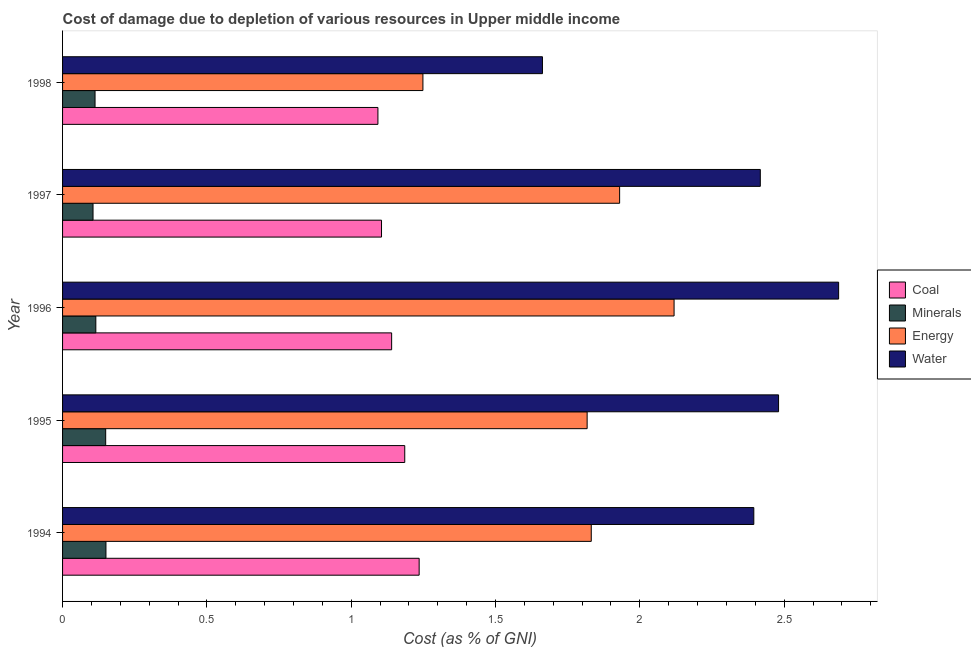How many different coloured bars are there?
Offer a terse response. 4. Are the number of bars on each tick of the Y-axis equal?
Offer a terse response. Yes. How many bars are there on the 3rd tick from the top?
Your answer should be very brief. 4. How many bars are there on the 3rd tick from the bottom?
Your answer should be compact. 4. What is the label of the 3rd group of bars from the top?
Your answer should be very brief. 1996. In how many cases, is the number of bars for a given year not equal to the number of legend labels?
Your response must be concise. 0. What is the cost of damage due to depletion of energy in 1997?
Provide a short and direct response. 1.93. Across all years, what is the maximum cost of damage due to depletion of energy?
Make the answer very short. 2.12. Across all years, what is the minimum cost of damage due to depletion of water?
Give a very brief answer. 1.66. What is the total cost of damage due to depletion of coal in the graph?
Offer a terse response. 5.76. What is the difference between the cost of damage due to depletion of minerals in 1995 and that in 1997?
Your answer should be very brief. 0.04. What is the difference between the cost of damage due to depletion of minerals in 1997 and the cost of damage due to depletion of coal in 1998?
Ensure brevity in your answer.  -0.99. What is the average cost of damage due to depletion of coal per year?
Your answer should be compact. 1.15. In the year 1997, what is the difference between the cost of damage due to depletion of water and cost of damage due to depletion of energy?
Make the answer very short. 0.49. In how many years, is the cost of damage due to depletion of energy greater than 1.3 %?
Your response must be concise. 4. What is the ratio of the cost of damage due to depletion of water in 1995 to that in 1996?
Make the answer very short. 0.92. Is the difference between the cost of damage due to depletion of coal in 1997 and 1998 greater than the difference between the cost of damage due to depletion of energy in 1997 and 1998?
Ensure brevity in your answer.  No. What is the difference between the highest and the second highest cost of damage due to depletion of water?
Ensure brevity in your answer.  0.21. What is the difference between the highest and the lowest cost of damage due to depletion of energy?
Give a very brief answer. 0.87. What does the 3rd bar from the top in 1995 represents?
Ensure brevity in your answer.  Minerals. What does the 4th bar from the bottom in 1998 represents?
Provide a short and direct response. Water. How many bars are there?
Provide a succinct answer. 20. Are all the bars in the graph horizontal?
Make the answer very short. Yes. How many years are there in the graph?
Make the answer very short. 5. Are the values on the major ticks of X-axis written in scientific E-notation?
Ensure brevity in your answer.  No. Does the graph contain any zero values?
Keep it short and to the point. No. Where does the legend appear in the graph?
Your response must be concise. Center right. How many legend labels are there?
Offer a terse response. 4. What is the title of the graph?
Keep it short and to the point. Cost of damage due to depletion of various resources in Upper middle income . Does "Secondary schools" appear as one of the legend labels in the graph?
Your answer should be very brief. No. What is the label or title of the X-axis?
Keep it short and to the point. Cost (as % of GNI). What is the label or title of the Y-axis?
Keep it short and to the point. Year. What is the Cost (as % of GNI) in Coal in 1994?
Provide a short and direct response. 1.24. What is the Cost (as % of GNI) of Minerals in 1994?
Offer a terse response. 0.15. What is the Cost (as % of GNI) of Energy in 1994?
Give a very brief answer. 1.83. What is the Cost (as % of GNI) of Water in 1994?
Your response must be concise. 2.39. What is the Cost (as % of GNI) in Coal in 1995?
Provide a short and direct response. 1.19. What is the Cost (as % of GNI) in Minerals in 1995?
Provide a short and direct response. 0.15. What is the Cost (as % of GNI) in Energy in 1995?
Provide a succinct answer. 1.82. What is the Cost (as % of GNI) of Water in 1995?
Provide a succinct answer. 2.48. What is the Cost (as % of GNI) of Coal in 1996?
Offer a very short reply. 1.14. What is the Cost (as % of GNI) of Minerals in 1996?
Give a very brief answer. 0.12. What is the Cost (as % of GNI) in Energy in 1996?
Offer a terse response. 2.12. What is the Cost (as % of GNI) in Water in 1996?
Make the answer very short. 2.69. What is the Cost (as % of GNI) in Coal in 1997?
Your answer should be compact. 1.11. What is the Cost (as % of GNI) of Minerals in 1997?
Your answer should be compact. 0.11. What is the Cost (as % of GNI) of Energy in 1997?
Your answer should be very brief. 1.93. What is the Cost (as % of GNI) of Water in 1997?
Your answer should be very brief. 2.42. What is the Cost (as % of GNI) of Coal in 1998?
Ensure brevity in your answer.  1.09. What is the Cost (as % of GNI) in Minerals in 1998?
Provide a succinct answer. 0.11. What is the Cost (as % of GNI) in Energy in 1998?
Provide a succinct answer. 1.25. What is the Cost (as % of GNI) of Water in 1998?
Keep it short and to the point. 1.66. Across all years, what is the maximum Cost (as % of GNI) of Coal?
Provide a short and direct response. 1.24. Across all years, what is the maximum Cost (as % of GNI) of Minerals?
Your response must be concise. 0.15. Across all years, what is the maximum Cost (as % of GNI) of Energy?
Provide a short and direct response. 2.12. Across all years, what is the maximum Cost (as % of GNI) in Water?
Your answer should be very brief. 2.69. Across all years, what is the minimum Cost (as % of GNI) of Coal?
Provide a short and direct response. 1.09. Across all years, what is the minimum Cost (as % of GNI) of Minerals?
Your response must be concise. 0.11. Across all years, what is the minimum Cost (as % of GNI) of Energy?
Provide a short and direct response. 1.25. Across all years, what is the minimum Cost (as % of GNI) in Water?
Your answer should be compact. 1.66. What is the total Cost (as % of GNI) in Coal in the graph?
Provide a short and direct response. 5.76. What is the total Cost (as % of GNI) of Minerals in the graph?
Your response must be concise. 0.63. What is the total Cost (as % of GNI) of Energy in the graph?
Your answer should be very brief. 8.95. What is the total Cost (as % of GNI) of Water in the graph?
Your response must be concise. 11.64. What is the difference between the Cost (as % of GNI) of Coal in 1994 and that in 1995?
Offer a very short reply. 0.05. What is the difference between the Cost (as % of GNI) of Minerals in 1994 and that in 1995?
Provide a short and direct response. 0. What is the difference between the Cost (as % of GNI) of Energy in 1994 and that in 1995?
Provide a succinct answer. 0.01. What is the difference between the Cost (as % of GNI) in Water in 1994 and that in 1995?
Offer a terse response. -0.09. What is the difference between the Cost (as % of GNI) of Coal in 1994 and that in 1996?
Offer a very short reply. 0.1. What is the difference between the Cost (as % of GNI) of Minerals in 1994 and that in 1996?
Your response must be concise. 0.04. What is the difference between the Cost (as % of GNI) in Energy in 1994 and that in 1996?
Keep it short and to the point. -0.29. What is the difference between the Cost (as % of GNI) of Water in 1994 and that in 1996?
Provide a succinct answer. -0.29. What is the difference between the Cost (as % of GNI) of Coal in 1994 and that in 1997?
Your answer should be compact. 0.13. What is the difference between the Cost (as % of GNI) of Minerals in 1994 and that in 1997?
Offer a very short reply. 0.04. What is the difference between the Cost (as % of GNI) of Energy in 1994 and that in 1997?
Provide a short and direct response. -0.1. What is the difference between the Cost (as % of GNI) in Water in 1994 and that in 1997?
Your answer should be very brief. -0.02. What is the difference between the Cost (as % of GNI) of Coal in 1994 and that in 1998?
Provide a succinct answer. 0.14. What is the difference between the Cost (as % of GNI) in Minerals in 1994 and that in 1998?
Provide a succinct answer. 0.04. What is the difference between the Cost (as % of GNI) of Energy in 1994 and that in 1998?
Your response must be concise. 0.58. What is the difference between the Cost (as % of GNI) of Water in 1994 and that in 1998?
Provide a succinct answer. 0.73. What is the difference between the Cost (as % of GNI) of Coal in 1995 and that in 1996?
Offer a terse response. 0.05. What is the difference between the Cost (as % of GNI) in Minerals in 1995 and that in 1996?
Give a very brief answer. 0.03. What is the difference between the Cost (as % of GNI) of Energy in 1995 and that in 1996?
Your response must be concise. -0.3. What is the difference between the Cost (as % of GNI) of Water in 1995 and that in 1996?
Give a very brief answer. -0.21. What is the difference between the Cost (as % of GNI) of Coal in 1995 and that in 1997?
Provide a short and direct response. 0.08. What is the difference between the Cost (as % of GNI) in Minerals in 1995 and that in 1997?
Make the answer very short. 0.04. What is the difference between the Cost (as % of GNI) of Energy in 1995 and that in 1997?
Your answer should be compact. -0.11. What is the difference between the Cost (as % of GNI) in Water in 1995 and that in 1997?
Your answer should be very brief. 0.06. What is the difference between the Cost (as % of GNI) of Coal in 1995 and that in 1998?
Provide a succinct answer. 0.09. What is the difference between the Cost (as % of GNI) in Minerals in 1995 and that in 1998?
Keep it short and to the point. 0.04. What is the difference between the Cost (as % of GNI) in Energy in 1995 and that in 1998?
Provide a succinct answer. 0.57. What is the difference between the Cost (as % of GNI) of Water in 1995 and that in 1998?
Offer a terse response. 0.82. What is the difference between the Cost (as % of GNI) of Coal in 1996 and that in 1997?
Give a very brief answer. 0.04. What is the difference between the Cost (as % of GNI) in Minerals in 1996 and that in 1997?
Your answer should be very brief. 0.01. What is the difference between the Cost (as % of GNI) of Energy in 1996 and that in 1997?
Your response must be concise. 0.19. What is the difference between the Cost (as % of GNI) in Water in 1996 and that in 1997?
Ensure brevity in your answer.  0.27. What is the difference between the Cost (as % of GNI) in Coal in 1996 and that in 1998?
Offer a very short reply. 0.05. What is the difference between the Cost (as % of GNI) of Minerals in 1996 and that in 1998?
Offer a very short reply. 0. What is the difference between the Cost (as % of GNI) of Energy in 1996 and that in 1998?
Your answer should be very brief. 0.87. What is the difference between the Cost (as % of GNI) of Water in 1996 and that in 1998?
Your answer should be compact. 1.03. What is the difference between the Cost (as % of GNI) in Coal in 1997 and that in 1998?
Provide a succinct answer. 0.01. What is the difference between the Cost (as % of GNI) in Minerals in 1997 and that in 1998?
Provide a succinct answer. -0.01. What is the difference between the Cost (as % of GNI) of Energy in 1997 and that in 1998?
Your answer should be very brief. 0.68. What is the difference between the Cost (as % of GNI) in Water in 1997 and that in 1998?
Make the answer very short. 0.75. What is the difference between the Cost (as % of GNI) in Coal in 1994 and the Cost (as % of GNI) in Minerals in 1995?
Give a very brief answer. 1.09. What is the difference between the Cost (as % of GNI) in Coal in 1994 and the Cost (as % of GNI) in Energy in 1995?
Your response must be concise. -0.58. What is the difference between the Cost (as % of GNI) in Coal in 1994 and the Cost (as % of GNI) in Water in 1995?
Offer a terse response. -1.25. What is the difference between the Cost (as % of GNI) of Minerals in 1994 and the Cost (as % of GNI) of Energy in 1995?
Offer a terse response. -1.67. What is the difference between the Cost (as % of GNI) in Minerals in 1994 and the Cost (as % of GNI) in Water in 1995?
Keep it short and to the point. -2.33. What is the difference between the Cost (as % of GNI) in Energy in 1994 and the Cost (as % of GNI) in Water in 1995?
Offer a terse response. -0.65. What is the difference between the Cost (as % of GNI) in Coal in 1994 and the Cost (as % of GNI) in Minerals in 1996?
Offer a terse response. 1.12. What is the difference between the Cost (as % of GNI) of Coal in 1994 and the Cost (as % of GNI) of Energy in 1996?
Keep it short and to the point. -0.88. What is the difference between the Cost (as % of GNI) in Coal in 1994 and the Cost (as % of GNI) in Water in 1996?
Your answer should be very brief. -1.45. What is the difference between the Cost (as % of GNI) in Minerals in 1994 and the Cost (as % of GNI) in Energy in 1996?
Offer a terse response. -1.97. What is the difference between the Cost (as % of GNI) of Minerals in 1994 and the Cost (as % of GNI) of Water in 1996?
Ensure brevity in your answer.  -2.54. What is the difference between the Cost (as % of GNI) of Energy in 1994 and the Cost (as % of GNI) of Water in 1996?
Make the answer very short. -0.86. What is the difference between the Cost (as % of GNI) of Coal in 1994 and the Cost (as % of GNI) of Minerals in 1997?
Offer a very short reply. 1.13. What is the difference between the Cost (as % of GNI) in Coal in 1994 and the Cost (as % of GNI) in Energy in 1997?
Make the answer very short. -0.69. What is the difference between the Cost (as % of GNI) of Coal in 1994 and the Cost (as % of GNI) of Water in 1997?
Give a very brief answer. -1.18. What is the difference between the Cost (as % of GNI) of Minerals in 1994 and the Cost (as % of GNI) of Energy in 1997?
Offer a very short reply. -1.78. What is the difference between the Cost (as % of GNI) in Minerals in 1994 and the Cost (as % of GNI) in Water in 1997?
Your response must be concise. -2.27. What is the difference between the Cost (as % of GNI) in Energy in 1994 and the Cost (as % of GNI) in Water in 1997?
Your response must be concise. -0.59. What is the difference between the Cost (as % of GNI) of Coal in 1994 and the Cost (as % of GNI) of Minerals in 1998?
Offer a very short reply. 1.12. What is the difference between the Cost (as % of GNI) in Coal in 1994 and the Cost (as % of GNI) in Energy in 1998?
Provide a succinct answer. -0.01. What is the difference between the Cost (as % of GNI) in Coal in 1994 and the Cost (as % of GNI) in Water in 1998?
Offer a very short reply. -0.43. What is the difference between the Cost (as % of GNI) of Minerals in 1994 and the Cost (as % of GNI) of Energy in 1998?
Provide a succinct answer. -1.1. What is the difference between the Cost (as % of GNI) in Minerals in 1994 and the Cost (as % of GNI) in Water in 1998?
Ensure brevity in your answer.  -1.51. What is the difference between the Cost (as % of GNI) of Energy in 1994 and the Cost (as % of GNI) of Water in 1998?
Make the answer very short. 0.17. What is the difference between the Cost (as % of GNI) of Coal in 1995 and the Cost (as % of GNI) of Minerals in 1996?
Offer a terse response. 1.07. What is the difference between the Cost (as % of GNI) of Coal in 1995 and the Cost (as % of GNI) of Energy in 1996?
Offer a very short reply. -0.93. What is the difference between the Cost (as % of GNI) in Coal in 1995 and the Cost (as % of GNI) in Water in 1996?
Make the answer very short. -1.5. What is the difference between the Cost (as % of GNI) in Minerals in 1995 and the Cost (as % of GNI) in Energy in 1996?
Your response must be concise. -1.97. What is the difference between the Cost (as % of GNI) of Minerals in 1995 and the Cost (as % of GNI) of Water in 1996?
Ensure brevity in your answer.  -2.54. What is the difference between the Cost (as % of GNI) in Energy in 1995 and the Cost (as % of GNI) in Water in 1996?
Keep it short and to the point. -0.87. What is the difference between the Cost (as % of GNI) in Coal in 1995 and the Cost (as % of GNI) in Minerals in 1997?
Ensure brevity in your answer.  1.08. What is the difference between the Cost (as % of GNI) in Coal in 1995 and the Cost (as % of GNI) in Energy in 1997?
Offer a very short reply. -0.74. What is the difference between the Cost (as % of GNI) in Coal in 1995 and the Cost (as % of GNI) in Water in 1997?
Ensure brevity in your answer.  -1.23. What is the difference between the Cost (as % of GNI) in Minerals in 1995 and the Cost (as % of GNI) in Energy in 1997?
Provide a succinct answer. -1.78. What is the difference between the Cost (as % of GNI) of Minerals in 1995 and the Cost (as % of GNI) of Water in 1997?
Ensure brevity in your answer.  -2.27. What is the difference between the Cost (as % of GNI) in Energy in 1995 and the Cost (as % of GNI) in Water in 1997?
Offer a very short reply. -0.6. What is the difference between the Cost (as % of GNI) of Coal in 1995 and the Cost (as % of GNI) of Minerals in 1998?
Your answer should be compact. 1.07. What is the difference between the Cost (as % of GNI) of Coal in 1995 and the Cost (as % of GNI) of Energy in 1998?
Provide a succinct answer. -0.06. What is the difference between the Cost (as % of GNI) of Coal in 1995 and the Cost (as % of GNI) of Water in 1998?
Give a very brief answer. -0.48. What is the difference between the Cost (as % of GNI) of Minerals in 1995 and the Cost (as % of GNI) of Energy in 1998?
Provide a succinct answer. -1.1. What is the difference between the Cost (as % of GNI) of Minerals in 1995 and the Cost (as % of GNI) of Water in 1998?
Provide a succinct answer. -1.51. What is the difference between the Cost (as % of GNI) in Energy in 1995 and the Cost (as % of GNI) in Water in 1998?
Your response must be concise. 0.15. What is the difference between the Cost (as % of GNI) in Coal in 1996 and the Cost (as % of GNI) in Minerals in 1997?
Offer a terse response. 1.03. What is the difference between the Cost (as % of GNI) of Coal in 1996 and the Cost (as % of GNI) of Energy in 1997?
Provide a short and direct response. -0.79. What is the difference between the Cost (as % of GNI) of Coal in 1996 and the Cost (as % of GNI) of Water in 1997?
Make the answer very short. -1.28. What is the difference between the Cost (as % of GNI) in Minerals in 1996 and the Cost (as % of GNI) in Energy in 1997?
Provide a succinct answer. -1.81. What is the difference between the Cost (as % of GNI) of Minerals in 1996 and the Cost (as % of GNI) of Water in 1997?
Your response must be concise. -2.3. What is the difference between the Cost (as % of GNI) of Energy in 1996 and the Cost (as % of GNI) of Water in 1997?
Give a very brief answer. -0.3. What is the difference between the Cost (as % of GNI) of Coal in 1996 and the Cost (as % of GNI) of Minerals in 1998?
Keep it short and to the point. 1.03. What is the difference between the Cost (as % of GNI) in Coal in 1996 and the Cost (as % of GNI) in Energy in 1998?
Offer a very short reply. -0.11. What is the difference between the Cost (as % of GNI) in Coal in 1996 and the Cost (as % of GNI) in Water in 1998?
Your response must be concise. -0.52. What is the difference between the Cost (as % of GNI) of Minerals in 1996 and the Cost (as % of GNI) of Energy in 1998?
Your answer should be compact. -1.13. What is the difference between the Cost (as % of GNI) of Minerals in 1996 and the Cost (as % of GNI) of Water in 1998?
Provide a succinct answer. -1.55. What is the difference between the Cost (as % of GNI) of Energy in 1996 and the Cost (as % of GNI) of Water in 1998?
Provide a succinct answer. 0.46. What is the difference between the Cost (as % of GNI) in Coal in 1997 and the Cost (as % of GNI) in Energy in 1998?
Offer a terse response. -0.14. What is the difference between the Cost (as % of GNI) of Coal in 1997 and the Cost (as % of GNI) of Water in 1998?
Make the answer very short. -0.56. What is the difference between the Cost (as % of GNI) of Minerals in 1997 and the Cost (as % of GNI) of Energy in 1998?
Provide a short and direct response. -1.14. What is the difference between the Cost (as % of GNI) in Minerals in 1997 and the Cost (as % of GNI) in Water in 1998?
Offer a very short reply. -1.56. What is the difference between the Cost (as % of GNI) of Energy in 1997 and the Cost (as % of GNI) of Water in 1998?
Keep it short and to the point. 0.27. What is the average Cost (as % of GNI) in Coal per year?
Provide a short and direct response. 1.15. What is the average Cost (as % of GNI) in Minerals per year?
Provide a succinct answer. 0.13. What is the average Cost (as % of GNI) of Energy per year?
Your response must be concise. 1.79. What is the average Cost (as % of GNI) in Water per year?
Your answer should be very brief. 2.33. In the year 1994, what is the difference between the Cost (as % of GNI) of Coal and Cost (as % of GNI) of Minerals?
Your response must be concise. 1.09. In the year 1994, what is the difference between the Cost (as % of GNI) in Coal and Cost (as % of GNI) in Energy?
Ensure brevity in your answer.  -0.6. In the year 1994, what is the difference between the Cost (as % of GNI) in Coal and Cost (as % of GNI) in Water?
Offer a very short reply. -1.16. In the year 1994, what is the difference between the Cost (as % of GNI) in Minerals and Cost (as % of GNI) in Energy?
Your response must be concise. -1.68. In the year 1994, what is the difference between the Cost (as % of GNI) in Minerals and Cost (as % of GNI) in Water?
Provide a short and direct response. -2.24. In the year 1994, what is the difference between the Cost (as % of GNI) in Energy and Cost (as % of GNI) in Water?
Ensure brevity in your answer.  -0.56. In the year 1995, what is the difference between the Cost (as % of GNI) of Coal and Cost (as % of GNI) of Minerals?
Your answer should be very brief. 1.04. In the year 1995, what is the difference between the Cost (as % of GNI) of Coal and Cost (as % of GNI) of Energy?
Make the answer very short. -0.63. In the year 1995, what is the difference between the Cost (as % of GNI) of Coal and Cost (as % of GNI) of Water?
Provide a short and direct response. -1.3. In the year 1995, what is the difference between the Cost (as % of GNI) in Minerals and Cost (as % of GNI) in Energy?
Provide a short and direct response. -1.67. In the year 1995, what is the difference between the Cost (as % of GNI) of Minerals and Cost (as % of GNI) of Water?
Make the answer very short. -2.33. In the year 1995, what is the difference between the Cost (as % of GNI) in Energy and Cost (as % of GNI) in Water?
Provide a succinct answer. -0.66. In the year 1996, what is the difference between the Cost (as % of GNI) in Coal and Cost (as % of GNI) in Minerals?
Offer a terse response. 1.02. In the year 1996, what is the difference between the Cost (as % of GNI) of Coal and Cost (as % of GNI) of Energy?
Provide a short and direct response. -0.98. In the year 1996, what is the difference between the Cost (as % of GNI) in Coal and Cost (as % of GNI) in Water?
Make the answer very short. -1.55. In the year 1996, what is the difference between the Cost (as % of GNI) in Minerals and Cost (as % of GNI) in Energy?
Ensure brevity in your answer.  -2. In the year 1996, what is the difference between the Cost (as % of GNI) in Minerals and Cost (as % of GNI) in Water?
Provide a succinct answer. -2.57. In the year 1996, what is the difference between the Cost (as % of GNI) of Energy and Cost (as % of GNI) of Water?
Provide a short and direct response. -0.57. In the year 1997, what is the difference between the Cost (as % of GNI) of Coal and Cost (as % of GNI) of Minerals?
Give a very brief answer. 1. In the year 1997, what is the difference between the Cost (as % of GNI) in Coal and Cost (as % of GNI) in Energy?
Your response must be concise. -0.82. In the year 1997, what is the difference between the Cost (as % of GNI) of Coal and Cost (as % of GNI) of Water?
Your response must be concise. -1.31. In the year 1997, what is the difference between the Cost (as % of GNI) in Minerals and Cost (as % of GNI) in Energy?
Offer a very short reply. -1.82. In the year 1997, what is the difference between the Cost (as % of GNI) in Minerals and Cost (as % of GNI) in Water?
Give a very brief answer. -2.31. In the year 1997, what is the difference between the Cost (as % of GNI) in Energy and Cost (as % of GNI) in Water?
Keep it short and to the point. -0.49. In the year 1998, what is the difference between the Cost (as % of GNI) of Coal and Cost (as % of GNI) of Minerals?
Your response must be concise. 0.98. In the year 1998, what is the difference between the Cost (as % of GNI) of Coal and Cost (as % of GNI) of Energy?
Your response must be concise. -0.16. In the year 1998, what is the difference between the Cost (as % of GNI) in Coal and Cost (as % of GNI) in Water?
Make the answer very short. -0.57. In the year 1998, what is the difference between the Cost (as % of GNI) in Minerals and Cost (as % of GNI) in Energy?
Your response must be concise. -1.14. In the year 1998, what is the difference between the Cost (as % of GNI) of Minerals and Cost (as % of GNI) of Water?
Give a very brief answer. -1.55. In the year 1998, what is the difference between the Cost (as % of GNI) in Energy and Cost (as % of GNI) in Water?
Offer a terse response. -0.41. What is the ratio of the Cost (as % of GNI) of Coal in 1994 to that in 1995?
Ensure brevity in your answer.  1.04. What is the ratio of the Cost (as % of GNI) in Energy in 1994 to that in 1995?
Make the answer very short. 1.01. What is the ratio of the Cost (as % of GNI) of Water in 1994 to that in 1995?
Provide a succinct answer. 0.97. What is the ratio of the Cost (as % of GNI) of Coal in 1994 to that in 1996?
Your response must be concise. 1.08. What is the ratio of the Cost (as % of GNI) in Minerals in 1994 to that in 1996?
Provide a succinct answer. 1.3. What is the ratio of the Cost (as % of GNI) of Energy in 1994 to that in 1996?
Your answer should be compact. 0.86. What is the ratio of the Cost (as % of GNI) of Water in 1994 to that in 1996?
Your answer should be compact. 0.89. What is the ratio of the Cost (as % of GNI) of Coal in 1994 to that in 1997?
Offer a very short reply. 1.12. What is the ratio of the Cost (as % of GNI) of Minerals in 1994 to that in 1997?
Your response must be concise. 1.42. What is the ratio of the Cost (as % of GNI) of Energy in 1994 to that in 1997?
Give a very brief answer. 0.95. What is the ratio of the Cost (as % of GNI) of Coal in 1994 to that in 1998?
Ensure brevity in your answer.  1.13. What is the ratio of the Cost (as % of GNI) of Minerals in 1994 to that in 1998?
Provide a succinct answer. 1.34. What is the ratio of the Cost (as % of GNI) in Energy in 1994 to that in 1998?
Your answer should be compact. 1.47. What is the ratio of the Cost (as % of GNI) of Water in 1994 to that in 1998?
Your answer should be compact. 1.44. What is the ratio of the Cost (as % of GNI) in Coal in 1995 to that in 1996?
Give a very brief answer. 1.04. What is the ratio of the Cost (as % of GNI) of Minerals in 1995 to that in 1996?
Offer a terse response. 1.3. What is the ratio of the Cost (as % of GNI) of Energy in 1995 to that in 1996?
Your answer should be compact. 0.86. What is the ratio of the Cost (as % of GNI) in Water in 1995 to that in 1996?
Your answer should be compact. 0.92. What is the ratio of the Cost (as % of GNI) of Coal in 1995 to that in 1997?
Provide a succinct answer. 1.07. What is the ratio of the Cost (as % of GNI) in Minerals in 1995 to that in 1997?
Keep it short and to the point. 1.42. What is the ratio of the Cost (as % of GNI) in Energy in 1995 to that in 1997?
Provide a succinct answer. 0.94. What is the ratio of the Cost (as % of GNI) in Water in 1995 to that in 1997?
Offer a terse response. 1.03. What is the ratio of the Cost (as % of GNI) in Coal in 1995 to that in 1998?
Offer a very short reply. 1.09. What is the ratio of the Cost (as % of GNI) of Minerals in 1995 to that in 1998?
Make the answer very short. 1.33. What is the ratio of the Cost (as % of GNI) in Energy in 1995 to that in 1998?
Offer a very short reply. 1.46. What is the ratio of the Cost (as % of GNI) of Water in 1995 to that in 1998?
Ensure brevity in your answer.  1.49. What is the ratio of the Cost (as % of GNI) in Coal in 1996 to that in 1997?
Offer a very short reply. 1.03. What is the ratio of the Cost (as % of GNI) in Minerals in 1996 to that in 1997?
Ensure brevity in your answer.  1.09. What is the ratio of the Cost (as % of GNI) of Energy in 1996 to that in 1997?
Your response must be concise. 1.1. What is the ratio of the Cost (as % of GNI) in Water in 1996 to that in 1997?
Make the answer very short. 1.11. What is the ratio of the Cost (as % of GNI) of Coal in 1996 to that in 1998?
Your answer should be very brief. 1.04. What is the ratio of the Cost (as % of GNI) of Minerals in 1996 to that in 1998?
Your answer should be compact. 1.02. What is the ratio of the Cost (as % of GNI) of Energy in 1996 to that in 1998?
Ensure brevity in your answer.  1.7. What is the ratio of the Cost (as % of GNI) in Water in 1996 to that in 1998?
Provide a succinct answer. 1.62. What is the ratio of the Cost (as % of GNI) of Coal in 1997 to that in 1998?
Your answer should be compact. 1.01. What is the ratio of the Cost (as % of GNI) in Minerals in 1997 to that in 1998?
Your answer should be very brief. 0.94. What is the ratio of the Cost (as % of GNI) of Energy in 1997 to that in 1998?
Your response must be concise. 1.55. What is the ratio of the Cost (as % of GNI) of Water in 1997 to that in 1998?
Offer a very short reply. 1.45. What is the difference between the highest and the second highest Cost (as % of GNI) in Coal?
Offer a terse response. 0.05. What is the difference between the highest and the second highest Cost (as % of GNI) of Minerals?
Your answer should be very brief. 0. What is the difference between the highest and the second highest Cost (as % of GNI) in Energy?
Provide a short and direct response. 0.19. What is the difference between the highest and the second highest Cost (as % of GNI) of Water?
Ensure brevity in your answer.  0.21. What is the difference between the highest and the lowest Cost (as % of GNI) of Coal?
Give a very brief answer. 0.14. What is the difference between the highest and the lowest Cost (as % of GNI) of Minerals?
Your answer should be compact. 0.04. What is the difference between the highest and the lowest Cost (as % of GNI) in Energy?
Provide a short and direct response. 0.87. What is the difference between the highest and the lowest Cost (as % of GNI) of Water?
Give a very brief answer. 1.03. 